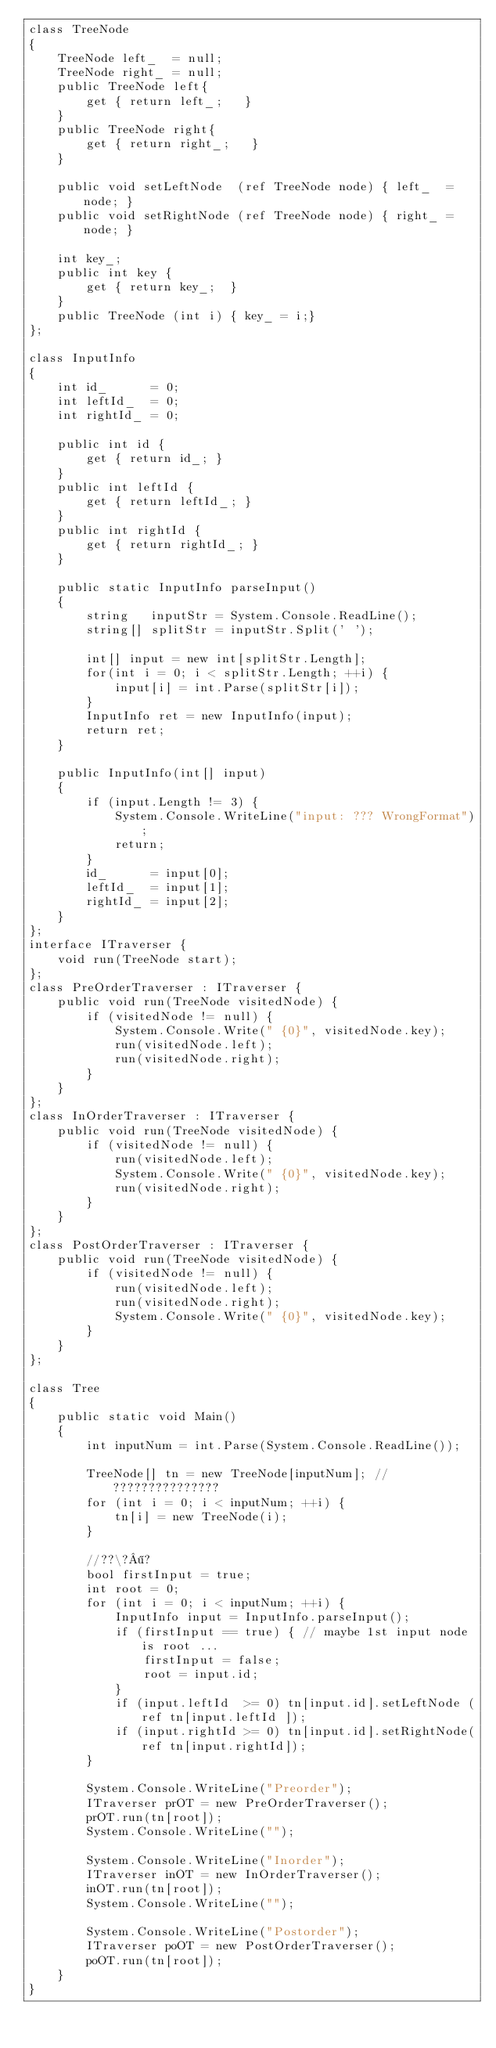<code> <loc_0><loc_0><loc_500><loc_500><_C#_>class TreeNode
{
	TreeNode left_  = null;
	TreeNode right_ = null;
	public TreeNode left{
		get { return left_;   }
	}
	public TreeNode right{
		get { return right_;   }
	}
	
	public void setLeftNode  (ref TreeNode node) { left_  = node; }
	public void setRightNode (ref TreeNode node) { right_ = node; }
	
	int key_;
	public int key {
		get { return key_;  }
	}
	public TreeNode (int i) { key_ = i;}
};

class InputInfo
{
	int id_      = 0;
	int leftId_  = 0;
	int rightId_ = 0;
	
	public int id {
		get { return id_; }
	}
	public int leftId {
		get { return leftId_; }
	}
	public int rightId {
		get { return rightId_; }
	}
	
	public static InputInfo parseInput()
	{
		string   inputStr = System.Console.ReadLine();
		string[] splitStr = inputStr.Split(' ');
		
		int[] input = new int[splitStr.Length];
		for(int i = 0; i < splitStr.Length; ++i) {
			input[i] = int.Parse(splitStr[i]);
		}
		InputInfo ret = new InputInfo(input);
		return ret;
	}
	
	public InputInfo(int[] input)
	{
		if (input.Length != 3) {
			System.Console.WriteLine("input: ??? WrongFormat");
			return;
		}
		id_      = input[0];
		leftId_  = input[1];
		rightId_ = input[2];
	}
};
interface ITraverser {
	void run(TreeNode start);
};
class PreOrderTraverser : ITraverser {
	public void run(TreeNode visitedNode) {
		if (visitedNode != null) {
			System.Console.Write(" {0}", visitedNode.key);
			run(visitedNode.left);
			run(visitedNode.right);
		}
	}
};
class InOrderTraverser : ITraverser {
	public void run(TreeNode visitedNode) {
		if (visitedNode != null) {
			run(visitedNode.left);
			System.Console.Write(" {0}", visitedNode.key);
			run(visitedNode.right);
		}
	}
};
class PostOrderTraverser : ITraverser {
	public void run(TreeNode visitedNode) {
		if (visitedNode != null) {
			run(visitedNode.left);
			run(visitedNode.right);
			System.Console.Write(" {0}", visitedNode.key);
		}
	}
};

class Tree
{
	public static void Main()
	{
		int inputNum = int.Parse(System.Console.ReadLine());
		
		TreeNode[] tn = new TreeNode[inputNum]; // ???????????????
		for (int i = 0; i < inputNum; ++i) {
			tn[i] = new TreeNode(i);
		}
		
		//??\?¶?
		bool firstInput = true;
		int root = 0;
		for (int i = 0; i < inputNum; ++i) {
			InputInfo input = InputInfo.parseInput();
			if (firstInput == true) { // maybe 1st input node is root ...
				firstInput = false;
				root = input.id;
			}
			if (input.leftId  >= 0) tn[input.id].setLeftNode (ref tn[input.leftId ]);
			if (input.rightId >= 0) tn[input.id].setRightNode(ref tn[input.rightId]);
		}
		
		System.Console.WriteLine("Preorder");
		ITraverser prOT = new PreOrderTraverser();
		prOT.run(tn[root]);
		System.Console.WriteLine("");
		
		System.Console.WriteLine("Inorder");
		ITraverser inOT = new InOrderTraverser();
		inOT.run(tn[root]);
		System.Console.WriteLine("");
		
		System.Console.WriteLine("Postorder");
		ITraverser poOT = new PostOrderTraverser();
		poOT.run(tn[root]);
	}
}</code> 